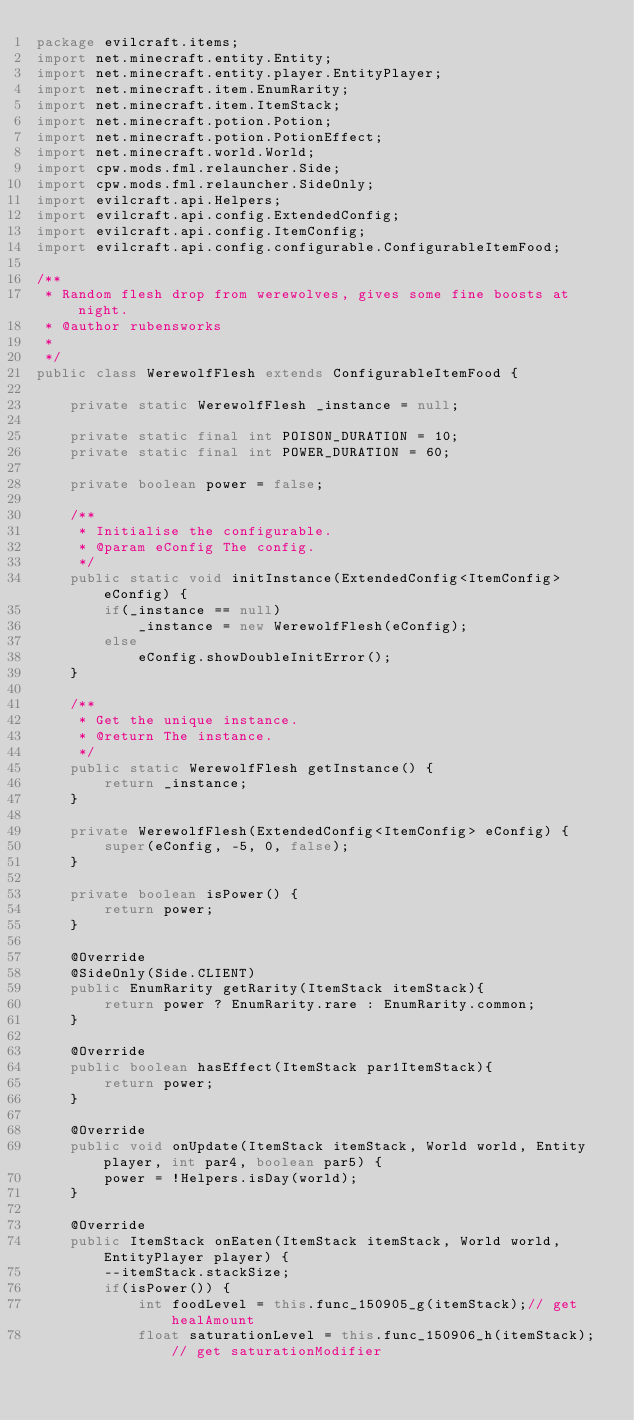Convert code to text. <code><loc_0><loc_0><loc_500><loc_500><_Java_>package evilcraft.items;
import net.minecraft.entity.Entity;
import net.minecraft.entity.player.EntityPlayer;
import net.minecraft.item.EnumRarity;
import net.minecraft.item.ItemStack;
import net.minecraft.potion.Potion;
import net.minecraft.potion.PotionEffect;
import net.minecraft.world.World;
import cpw.mods.fml.relauncher.Side;
import cpw.mods.fml.relauncher.SideOnly;
import evilcraft.api.Helpers;
import evilcraft.api.config.ExtendedConfig;
import evilcraft.api.config.ItemConfig;
import evilcraft.api.config.configurable.ConfigurableItemFood;

/**
 * Random flesh drop from werewolves, gives some fine boosts at night.
 * @author rubensworks
 *
 */
public class WerewolfFlesh extends ConfigurableItemFood {
    
    private static WerewolfFlesh _instance = null;
    
    private static final int POISON_DURATION = 10;
    private static final int POWER_DURATION = 60;
    
    private boolean power = false;
    
    /**
     * Initialise the configurable.
     * @param eConfig The config.
     */
    public static void initInstance(ExtendedConfig<ItemConfig> eConfig) {
        if(_instance == null)
            _instance = new WerewolfFlesh(eConfig);
        else
            eConfig.showDoubleInitError();
    }
    
    /**
     * Get the unique instance.
     * @return The instance.
     */
    public static WerewolfFlesh getInstance() {
        return _instance;
    }

    private WerewolfFlesh(ExtendedConfig<ItemConfig> eConfig) {
        super(eConfig, -5, 0, false);
    }
    
    private boolean isPower() {
        return power;
    }
    
    @Override
    @SideOnly(Side.CLIENT)
    public EnumRarity getRarity(ItemStack itemStack){
        return power ? EnumRarity.rare : EnumRarity.common;
    }
    
    @Override
    public boolean hasEffect(ItemStack par1ItemStack){
        return power;
    }
    
    @Override
    public void onUpdate(ItemStack itemStack, World world, Entity player, int par4, boolean par5) {
        power = !Helpers.isDay(world);
    }
    
    @Override
    public ItemStack onEaten(ItemStack itemStack, World world, EntityPlayer player) {
        --itemStack.stackSize;
        if(isPower()) {
        	int foodLevel = this.func_150905_g(itemStack);// get healAmount
        	float saturationLevel = this.func_150906_h(itemStack);// get saturationModifier</code> 